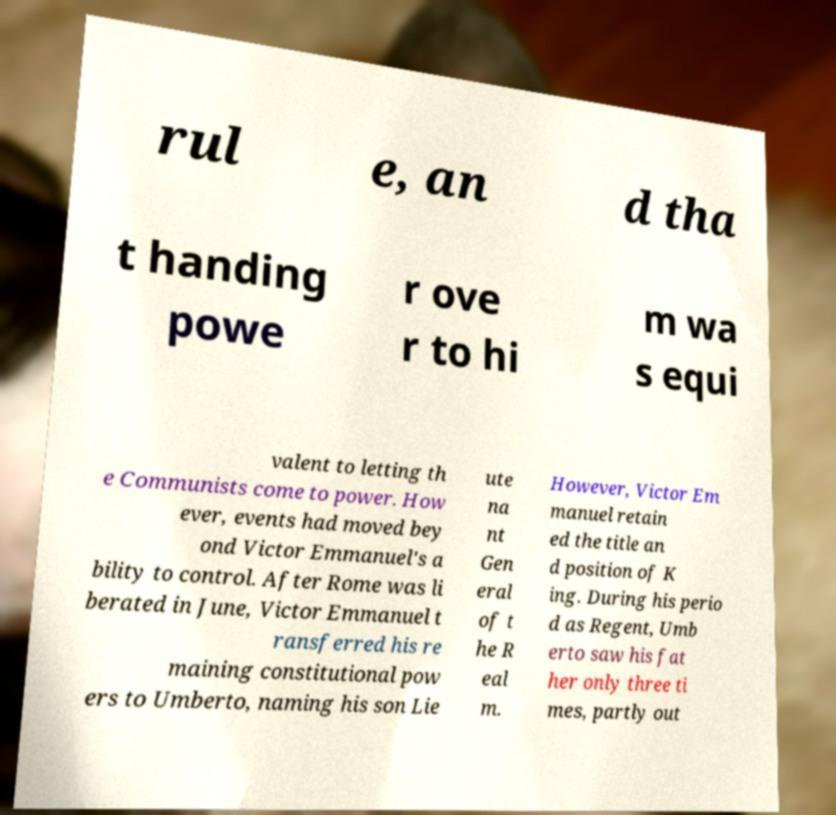There's text embedded in this image that I need extracted. Can you transcribe it verbatim? rul e, an d tha t handing powe r ove r to hi m wa s equi valent to letting th e Communists come to power. How ever, events had moved bey ond Victor Emmanuel's a bility to control. After Rome was li berated in June, Victor Emmanuel t ransferred his re maining constitutional pow ers to Umberto, naming his son Lie ute na nt Gen eral of t he R eal m. However, Victor Em manuel retain ed the title an d position of K ing. During his perio d as Regent, Umb erto saw his fat her only three ti mes, partly out 